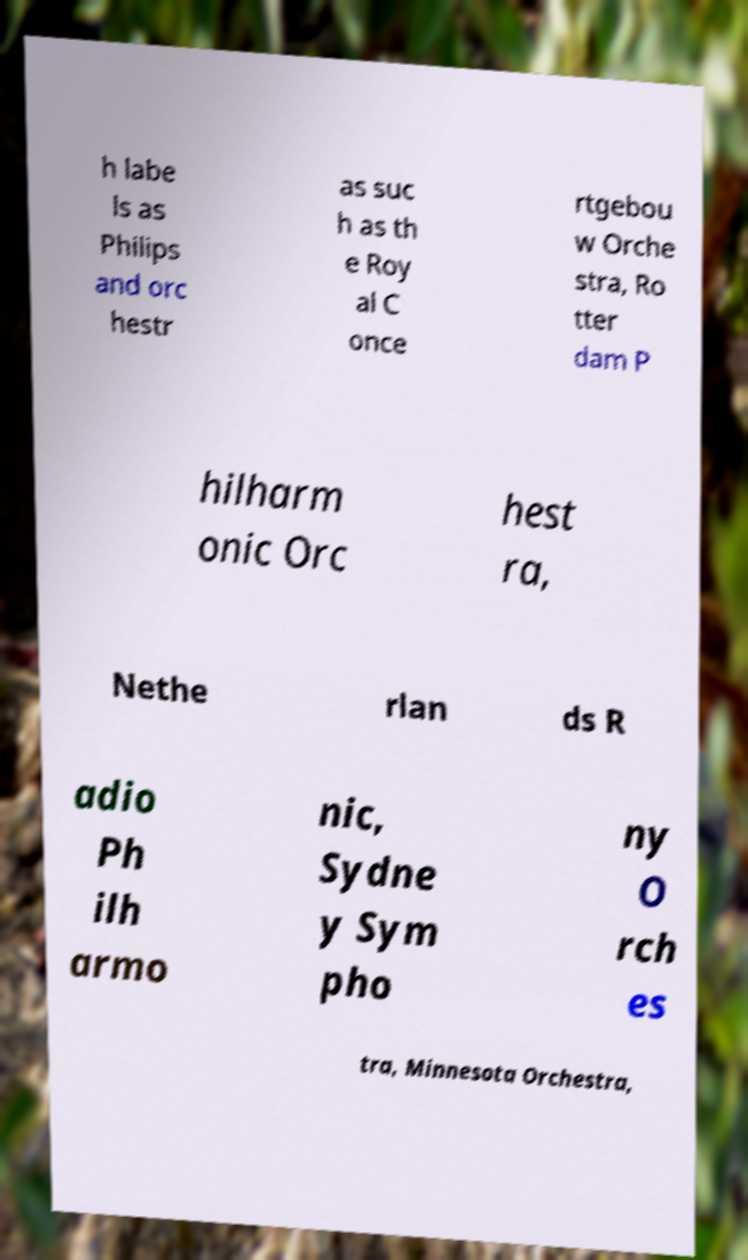Please read and relay the text visible in this image. What does it say? h labe ls as Philips and orc hestr as suc h as th e Roy al C once rtgebou w Orche stra, Ro tter dam P hilharm onic Orc hest ra, Nethe rlan ds R adio Ph ilh armo nic, Sydne y Sym pho ny O rch es tra, Minnesota Orchestra, 